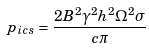Convert formula to latex. <formula><loc_0><loc_0><loc_500><loc_500>p _ { i c s } = \frac { 2 B ^ { 2 } \gamma ^ { 2 } h ^ { 2 } \Omega ^ { 2 } \sigma } { c \pi }</formula> 